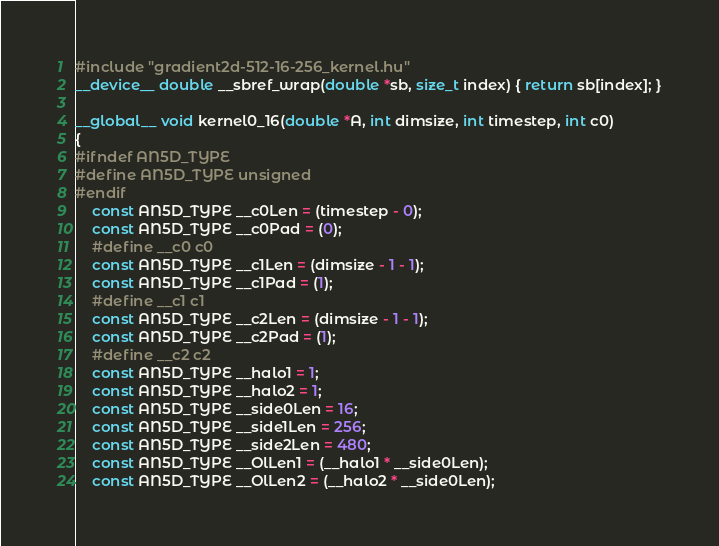<code> <loc_0><loc_0><loc_500><loc_500><_Cuda_>#include "gradient2d-512-16-256_kernel.hu"
__device__ double __sbref_wrap(double *sb, size_t index) { return sb[index]; }

__global__ void kernel0_16(double *A, int dimsize, int timestep, int c0)
{
#ifndef AN5D_TYPE
#define AN5D_TYPE unsigned
#endif
    const AN5D_TYPE __c0Len = (timestep - 0);
    const AN5D_TYPE __c0Pad = (0);
    #define __c0 c0
    const AN5D_TYPE __c1Len = (dimsize - 1 - 1);
    const AN5D_TYPE __c1Pad = (1);
    #define __c1 c1
    const AN5D_TYPE __c2Len = (dimsize - 1 - 1);
    const AN5D_TYPE __c2Pad = (1);
    #define __c2 c2
    const AN5D_TYPE __halo1 = 1;
    const AN5D_TYPE __halo2 = 1;
    const AN5D_TYPE __side0Len = 16;
    const AN5D_TYPE __side1Len = 256;
    const AN5D_TYPE __side2Len = 480;
    const AN5D_TYPE __OlLen1 = (__halo1 * __side0Len);
    const AN5D_TYPE __OlLen2 = (__halo2 * __side0Len);</code> 